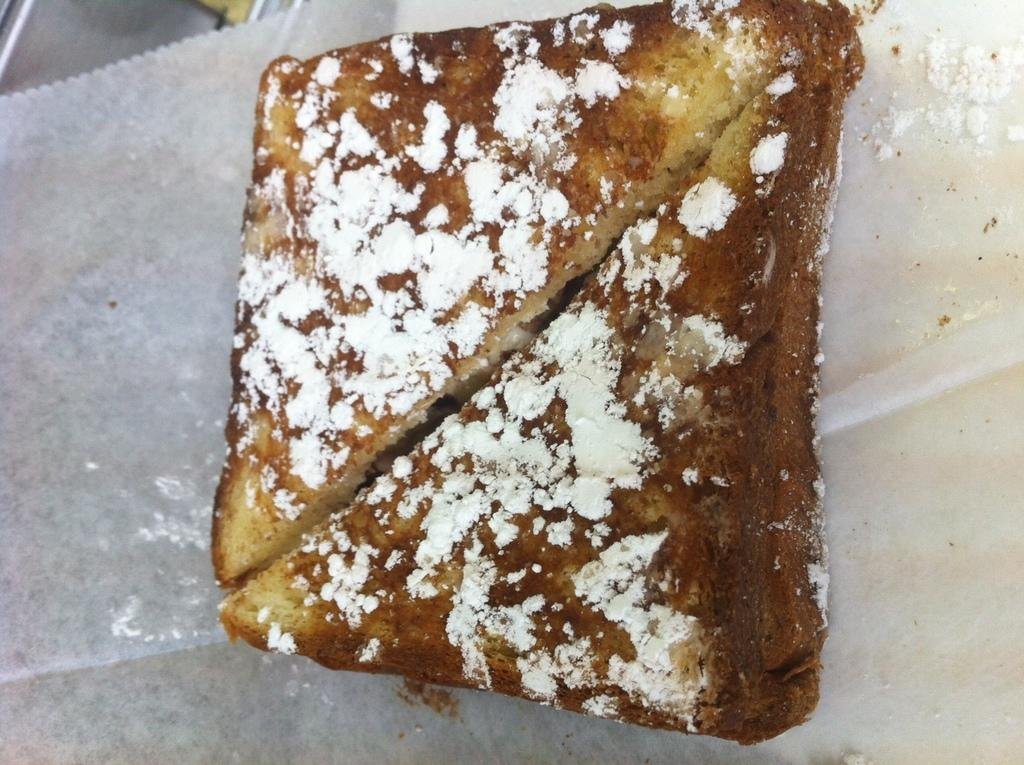What type of food can be seen in the image? The food in the image has brown and white colors. What is the color of the surface on which the food is placed? The food is on a white surface. Are there any feathers visible in the image? No, there are no feathers present in the image. Can you see a nest in the image? No, there is no nest present in the image. 